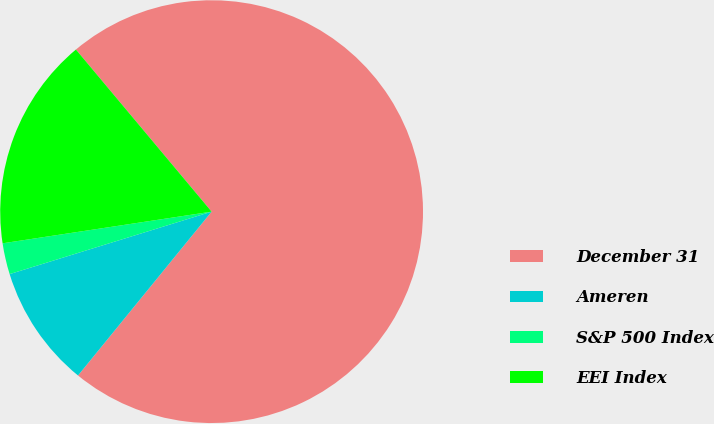Convert chart. <chart><loc_0><loc_0><loc_500><loc_500><pie_chart><fcel>December 31<fcel>Ameren<fcel>S&P 500 Index<fcel>EEI Index<nl><fcel>71.98%<fcel>9.34%<fcel>2.38%<fcel>16.3%<nl></chart> 